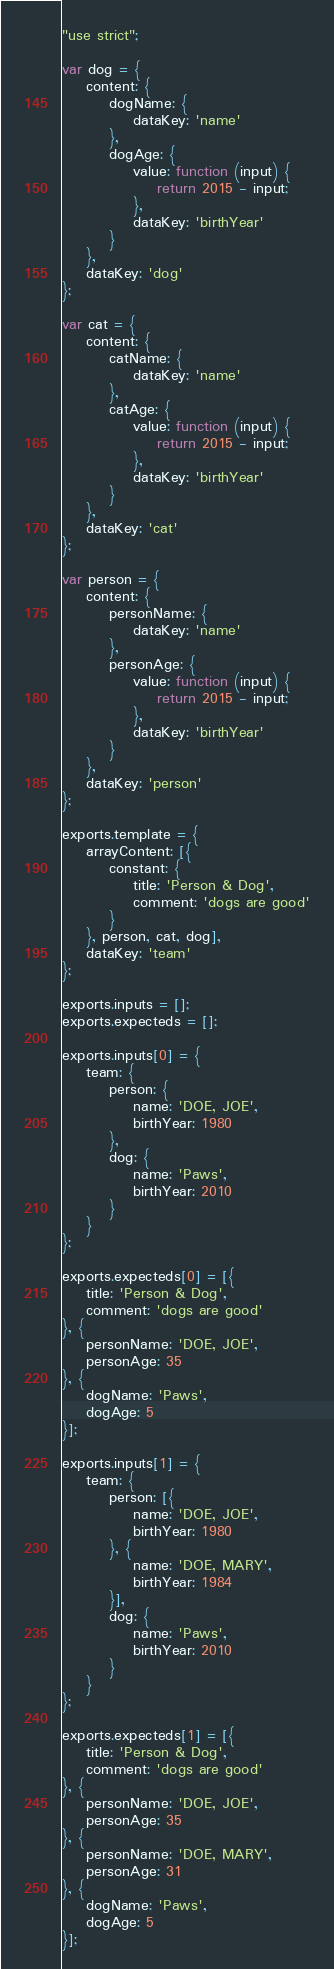Convert code to text. <code><loc_0><loc_0><loc_500><loc_500><_JavaScript_>"use strict";

var dog = {
    content: {
        dogName: {
            dataKey: 'name'
        },
        dogAge: {
            value: function (input) {
                return 2015 - input;
            },
            dataKey: 'birthYear'
        }
    },
    dataKey: 'dog'
};

var cat = {
    content: {
        catName: {
            dataKey: 'name'
        },
        catAge: {
            value: function (input) {
                return 2015 - input;
            },
            dataKey: 'birthYear'
        }
    },
    dataKey: 'cat'
};

var person = {
    content: {
        personName: {
            dataKey: 'name'
        },
        personAge: {
            value: function (input) {
                return 2015 - input;
            },
            dataKey: 'birthYear'
        }
    },
    dataKey: 'person'
};

exports.template = {
    arrayContent: [{
        constant: {
            title: 'Person & Dog',
            comment: 'dogs are good'
        }
    }, person, cat, dog],
    dataKey: 'team'
};

exports.inputs = [];
exports.expecteds = [];

exports.inputs[0] = {
    team: {
        person: {
            name: 'DOE, JOE',
            birthYear: 1980
        },
        dog: {
            name: 'Paws',
            birthYear: 2010
        }
    }
};

exports.expecteds[0] = [{
    title: 'Person & Dog',
    comment: 'dogs are good'
}, {
    personName: 'DOE, JOE',
    personAge: 35
}, {
    dogName: 'Paws',
    dogAge: 5
}];

exports.inputs[1] = {
    team: {
        person: [{
            name: 'DOE, JOE',
            birthYear: 1980
        }, {
            name: 'DOE, MARY',
            birthYear: 1984
        }],
        dog: {
            name: 'Paws',
            birthYear: 2010
        }
    }
};

exports.expecteds[1] = [{
    title: 'Person & Dog',
    comment: 'dogs are good'
}, {
    personName: 'DOE, JOE',
    personAge: 35
}, {
    personName: 'DOE, MARY',
    personAge: 31
}, {
    dogName: 'Paws',
    dogAge: 5
}];
</code> 